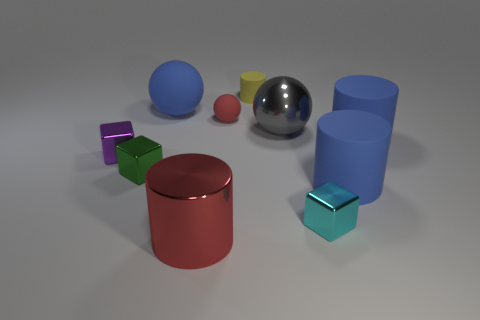There is a tiny cube on the right side of the big matte object that is to the left of the tiny cyan block; what is its material?
Give a very brief answer. Metal. What color is the tiny matte cylinder?
Keep it short and to the point. Yellow. Does the cylinder that is left of the tiny rubber ball have the same color as the big ball that is on the left side of the big red cylinder?
Your response must be concise. No. There is a blue thing that is the same shape as the gray thing; what size is it?
Provide a short and direct response. Large. Is there a small cylinder that has the same color as the big shiny cylinder?
Offer a very short reply. No. There is a big cylinder that is the same color as the tiny sphere; what material is it?
Your response must be concise. Metal. What number of small metal cubes are the same color as the tiny ball?
Offer a very short reply. 0. What number of objects are either large blue things to the left of the tiny yellow rubber thing or big brown matte things?
Offer a terse response. 1. What is the color of the large cylinder that is made of the same material as the green object?
Ensure brevity in your answer.  Red. Are there any yellow matte objects of the same size as the green shiny cube?
Your answer should be very brief. Yes. 